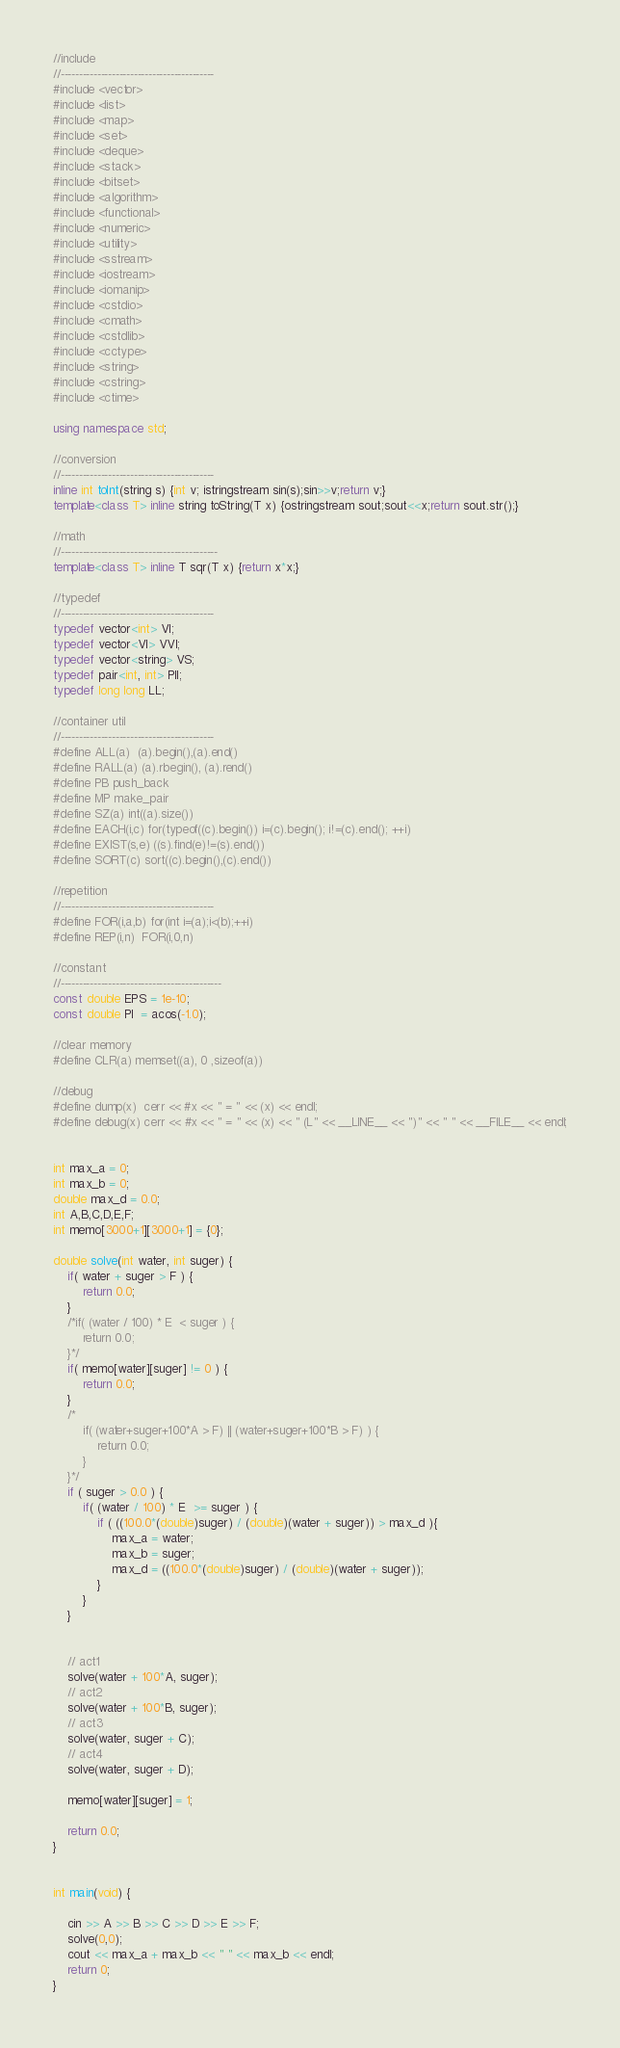Convert code to text. <code><loc_0><loc_0><loc_500><loc_500><_C++_>//include
//------------------------------------------
#include <vector>
#include <list>
#include <map>
#include <set>
#include <deque>
#include <stack>
#include <bitset>
#include <algorithm>
#include <functional>
#include <numeric>
#include <utility>
#include <sstream>
#include <iostream>
#include <iomanip>
#include <cstdio>
#include <cmath>
#include <cstdlib>
#include <cctype>
#include <string>
#include <cstring>
#include <ctime>

using namespace std;

//conversion
//------------------------------------------
inline int toInt(string s) {int v; istringstream sin(s);sin>>v;return v;}
template<class T> inline string toString(T x) {ostringstream sout;sout<<x;return sout.str();}

//math
//-------------------------------------------
template<class T> inline T sqr(T x) {return x*x;}

//typedef
//------------------------------------------
typedef vector<int> VI;
typedef vector<VI> VVI;
typedef vector<string> VS;
typedef pair<int, int> PII;
typedef long long LL;

//container util
//------------------------------------------
#define ALL(a)  (a).begin(),(a).end()
#define RALL(a) (a).rbegin(), (a).rend()
#define PB push_back
#define MP make_pair
#define SZ(a) int((a).size())
#define EACH(i,c) for(typeof((c).begin()) i=(c).begin(); i!=(c).end(); ++i)
#define EXIST(s,e) ((s).find(e)!=(s).end())
#define SORT(c) sort((c).begin(),(c).end())

//repetition
//------------------------------------------
#define FOR(i,a,b) for(int i=(a);i<(b);++i)
#define REP(i,n)  FOR(i,0,n)

//constant
//--------------------------------------------
const double EPS = 1e-10;
const double PI  = acos(-1.0);

//clear memory
#define CLR(a) memset((a), 0 ,sizeof(a))

//debug
#define dump(x)  cerr << #x << " = " << (x) << endl;
#define debug(x) cerr << #x << " = " << (x) << " (L" << __LINE__ << ")" << " " << __FILE__ << endl;


int max_a = 0;
int max_b = 0;
double max_d = 0.0;
int A,B,C,D,E,F;
int memo[3000+1][3000+1] = {0};

double solve(int water, int suger) {
	if( water + suger > F ) {
		return 0.0;
	}
	/*if( (water / 100) * E  < suger ) {
		return 0.0;
	}*/
	if( memo[water][suger] != 0 ) {
		return 0.0;
	}
	/*
		if( (water+suger+100*A > F) || (water+suger+100*B > F) ) {
			return 0.0;
		}
	}*/
	if ( suger > 0.0 ) {
		if( (water / 100) * E  >= suger ) {
			if ( ((100.0*(double)suger) / (double)(water + suger)) > max_d ){
				max_a = water;
				max_b = suger;
				max_d = ((100.0*(double)suger) / (double)(water + suger));
			}
		}
	}
	
	
	// act1
	solve(water + 100*A, suger);
	// act2
	solve(water + 100*B, suger);
	// act3
	solve(water, suger + C);
	// act4
	solve(water, suger + D);

	memo[water][suger] = 1;

	return 0.0;
}


int main(void) {
	
	cin >> A >> B >> C >> D >> E >> F;
	solve(0,0);
	cout << max_a + max_b << " " << max_b << endl;
	return 0;
}</code> 